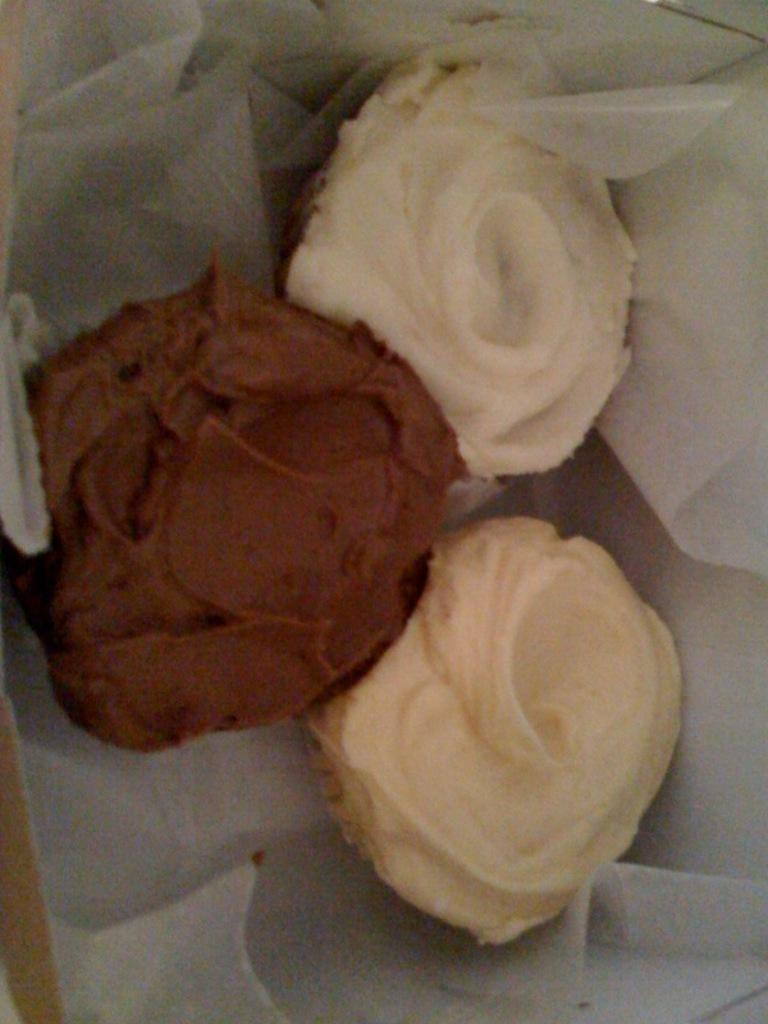What is present in the image? There are food items in the image. How are the food items arranged or presented? The food items are on a paper. How many snakes can be seen slithering around the food items in the image? There are no snakes present in the image; it only contains food items on a paper. 